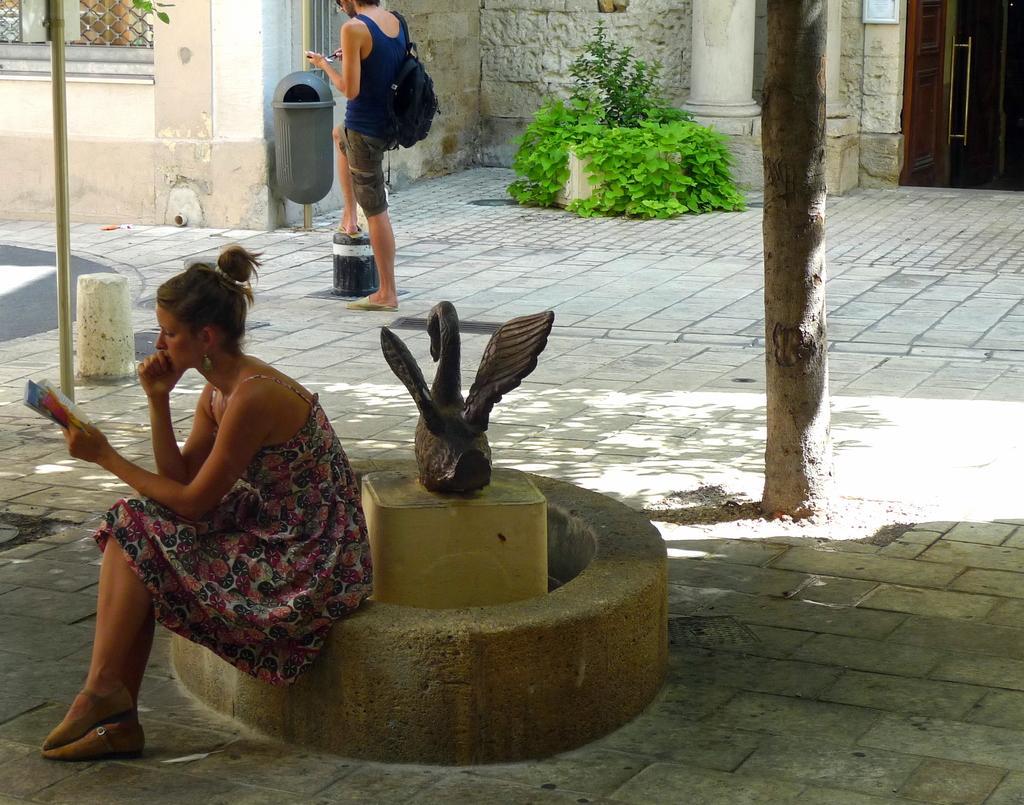Please provide a concise description of this image. In the center of the image, we can see a sculpture and there is a lady holding a book and sitting on the wall and in the background, there is a person wearing a bag and holding an object and there are plants and there is a building, a pillar and some poles, a mesh and a door. At the bottom, there is a road. 